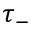<formula> <loc_0><loc_0><loc_500><loc_500>\tau _ { - }</formula> 